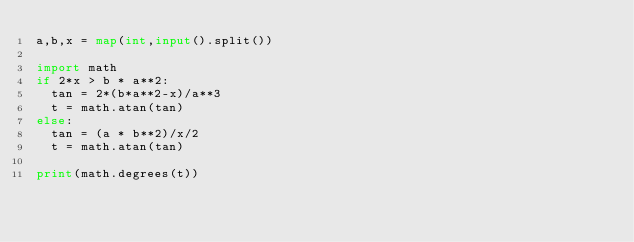Convert code to text. <code><loc_0><loc_0><loc_500><loc_500><_Python_>a,b,x = map(int,input().split())

import math
if 2*x > b * a**2:
  tan = 2*(b*a**2-x)/a**3
  t = math.atan(tan)
else:
  tan = (a * b**2)/x/2
  t = math.atan(tan)
  
print(math.degrees(t))</code> 